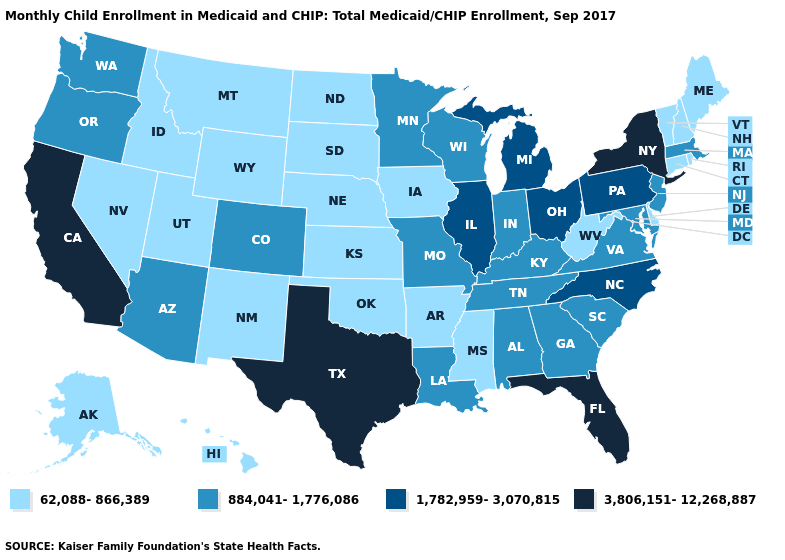What is the value of California?
Keep it brief. 3,806,151-12,268,887. Name the states that have a value in the range 1,782,959-3,070,815?
Give a very brief answer. Illinois, Michigan, North Carolina, Ohio, Pennsylvania. Does the first symbol in the legend represent the smallest category?
Short answer required. Yes. What is the lowest value in the West?
Be succinct. 62,088-866,389. How many symbols are there in the legend?
Answer briefly. 4. Name the states that have a value in the range 3,806,151-12,268,887?
Quick response, please. California, Florida, New York, Texas. What is the value of Indiana?
Quick response, please. 884,041-1,776,086. Name the states that have a value in the range 884,041-1,776,086?
Quick response, please. Alabama, Arizona, Colorado, Georgia, Indiana, Kentucky, Louisiana, Maryland, Massachusetts, Minnesota, Missouri, New Jersey, Oregon, South Carolina, Tennessee, Virginia, Washington, Wisconsin. Does the map have missing data?
Answer briefly. No. What is the value of Georgia?
Short answer required. 884,041-1,776,086. What is the highest value in the South ?
Give a very brief answer. 3,806,151-12,268,887. What is the value of Illinois?
Answer briefly. 1,782,959-3,070,815. What is the value of Maine?
Write a very short answer. 62,088-866,389. What is the value of Minnesota?
Concise answer only. 884,041-1,776,086. What is the highest value in states that border California?
Answer briefly. 884,041-1,776,086. 